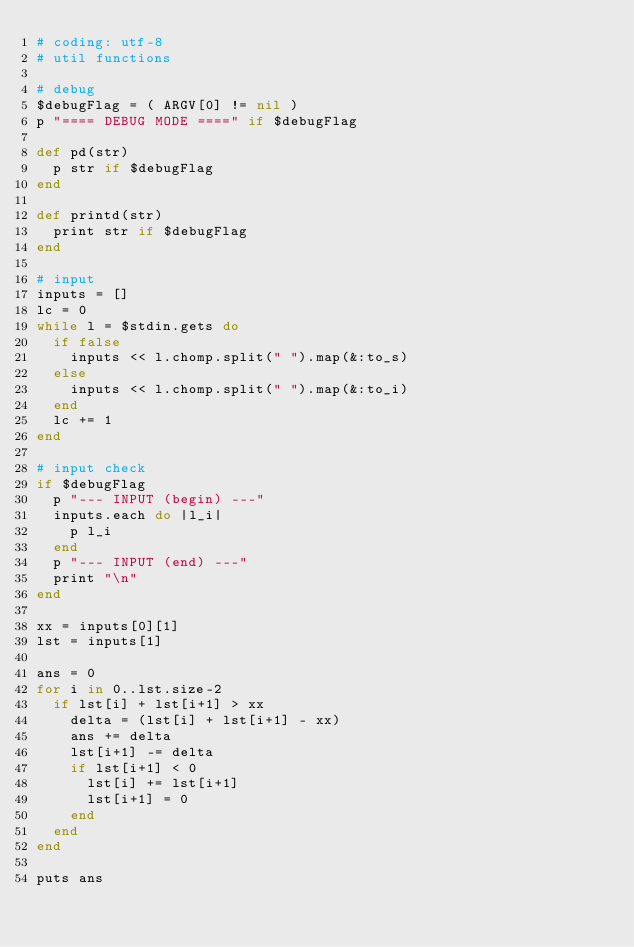Convert code to text. <code><loc_0><loc_0><loc_500><loc_500><_Ruby_># coding: utf-8
# util functions

# debug
$debugFlag = ( ARGV[0] != nil )
p "==== DEBUG MODE ====" if $debugFlag

def pd(str)
  p str if $debugFlag
end

def printd(str)
  print str if $debugFlag
end

# input
inputs = []
lc = 0
while l = $stdin.gets do
  if false
    inputs << l.chomp.split(" ").map(&:to_s)
  else
    inputs << l.chomp.split(" ").map(&:to_i)
  end
  lc += 1
end

# input check
if $debugFlag
  p "--- INPUT (begin) ---"
  inputs.each do |l_i|
    p l_i
  end
  p "--- INPUT (end) ---"
  print "\n"
end

xx = inputs[0][1]
lst = inputs[1]

ans = 0
for i in 0..lst.size-2
  if lst[i] + lst[i+1] > xx
    delta = (lst[i] + lst[i+1] - xx)
    ans += delta
    lst[i+1] -= delta
    if lst[i+1] < 0
      lst[i] += lst[i+1]
      lst[i+1] = 0
    end
  end
end

puts ans

</code> 